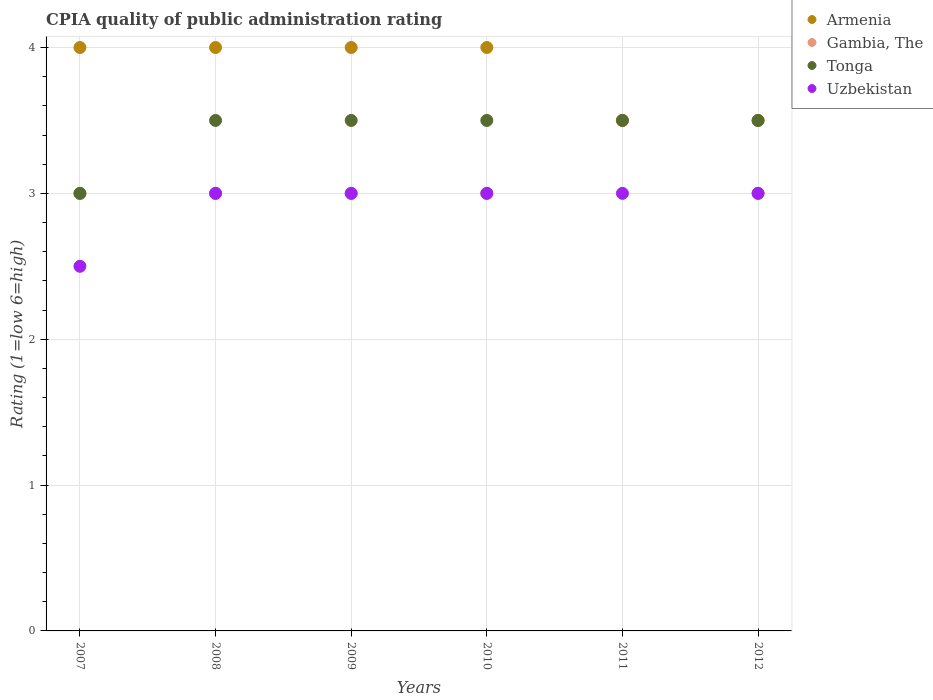How many different coloured dotlines are there?
Your answer should be compact. 4. Is the number of dotlines equal to the number of legend labels?
Provide a succinct answer. Yes. Across all years, what is the maximum CPIA rating in Armenia?
Offer a terse response. 4. Across all years, what is the minimum CPIA rating in Gambia, The?
Give a very brief answer. 3. In which year was the CPIA rating in Gambia, The minimum?
Offer a terse response. 2007. What is the total CPIA rating in Tonga in the graph?
Offer a terse response. 20.5. What is the difference between the CPIA rating in Gambia, The in 2011 and the CPIA rating in Uzbekistan in 2007?
Offer a terse response. 1. What is the average CPIA rating in Uzbekistan per year?
Ensure brevity in your answer.  2.92. In the year 2008, what is the difference between the CPIA rating in Uzbekistan and CPIA rating in Armenia?
Offer a terse response. -1. What is the ratio of the CPIA rating in Tonga in 2007 to that in 2010?
Your answer should be compact. 0.86. What is the difference between the highest and the second highest CPIA rating in Tonga?
Provide a succinct answer. 0. What is the difference between the highest and the lowest CPIA rating in Tonga?
Keep it short and to the point. 0.5. In how many years, is the CPIA rating in Armenia greater than the average CPIA rating in Armenia taken over all years?
Give a very brief answer. 4. Is it the case that in every year, the sum of the CPIA rating in Armenia and CPIA rating in Uzbekistan  is greater than the sum of CPIA rating in Gambia, The and CPIA rating in Tonga?
Provide a succinct answer. No. Is it the case that in every year, the sum of the CPIA rating in Tonga and CPIA rating in Gambia, The  is greater than the CPIA rating in Uzbekistan?
Your response must be concise. Yes. Does the CPIA rating in Tonga monotonically increase over the years?
Offer a terse response. No. Is the CPIA rating in Armenia strictly greater than the CPIA rating in Uzbekistan over the years?
Your answer should be very brief. Yes. How many dotlines are there?
Ensure brevity in your answer.  4. How many years are there in the graph?
Provide a short and direct response. 6. What is the difference between two consecutive major ticks on the Y-axis?
Keep it short and to the point. 1. Does the graph contain any zero values?
Offer a terse response. No. Does the graph contain grids?
Give a very brief answer. Yes. Where does the legend appear in the graph?
Provide a succinct answer. Top right. How many legend labels are there?
Your answer should be compact. 4. How are the legend labels stacked?
Give a very brief answer. Vertical. What is the title of the graph?
Give a very brief answer. CPIA quality of public administration rating. What is the Rating (1=low 6=high) of Armenia in 2007?
Offer a very short reply. 4. What is the Rating (1=low 6=high) of Tonga in 2007?
Provide a short and direct response. 3. What is the Rating (1=low 6=high) in Armenia in 2008?
Ensure brevity in your answer.  4. What is the Rating (1=low 6=high) of Uzbekistan in 2008?
Provide a short and direct response. 3. What is the Rating (1=low 6=high) of Gambia, The in 2009?
Give a very brief answer. 3. What is the Rating (1=low 6=high) of Tonga in 2009?
Make the answer very short. 3.5. What is the Rating (1=low 6=high) of Uzbekistan in 2009?
Make the answer very short. 3. What is the Rating (1=low 6=high) of Tonga in 2010?
Ensure brevity in your answer.  3.5. What is the Rating (1=low 6=high) in Uzbekistan in 2010?
Your answer should be compact. 3. What is the Rating (1=low 6=high) in Gambia, The in 2011?
Provide a short and direct response. 3.5. What is the Rating (1=low 6=high) in Tonga in 2011?
Ensure brevity in your answer.  3.5. What is the Rating (1=low 6=high) in Uzbekistan in 2011?
Ensure brevity in your answer.  3. What is the Rating (1=low 6=high) of Armenia in 2012?
Ensure brevity in your answer.  3.5. What is the Rating (1=low 6=high) of Tonga in 2012?
Ensure brevity in your answer.  3.5. Across all years, what is the maximum Rating (1=low 6=high) in Armenia?
Your answer should be compact. 4. Across all years, what is the maximum Rating (1=low 6=high) in Gambia, The?
Provide a short and direct response. 3.5. Across all years, what is the maximum Rating (1=low 6=high) in Tonga?
Make the answer very short. 3.5. Across all years, what is the minimum Rating (1=low 6=high) of Tonga?
Give a very brief answer. 3. What is the total Rating (1=low 6=high) of Tonga in the graph?
Ensure brevity in your answer.  20.5. What is the total Rating (1=low 6=high) in Uzbekistan in the graph?
Provide a short and direct response. 17.5. What is the difference between the Rating (1=low 6=high) of Uzbekistan in 2007 and that in 2008?
Offer a very short reply. -0.5. What is the difference between the Rating (1=low 6=high) of Armenia in 2007 and that in 2009?
Provide a short and direct response. 0. What is the difference between the Rating (1=low 6=high) in Gambia, The in 2007 and that in 2009?
Keep it short and to the point. 0. What is the difference between the Rating (1=low 6=high) of Uzbekistan in 2007 and that in 2009?
Your response must be concise. -0.5. What is the difference between the Rating (1=low 6=high) in Uzbekistan in 2007 and that in 2010?
Give a very brief answer. -0.5. What is the difference between the Rating (1=low 6=high) of Armenia in 2007 and that in 2011?
Offer a terse response. 0.5. What is the difference between the Rating (1=low 6=high) in Uzbekistan in 2007 and that in 2011?
Offer a very short reply. -0.5. What is the difference between the Rating (1=low 6=high) in Armenia in 2007 and that in 2012?
Your answer should be compact. 0.5. What is the difference between the Rating (1=low 6=high) of Gambia, The in 2007 and that in 2012?
Give a very brief answer. 0. What is the difference between the Rating (1=low 6=high) in Tonga in 2007 and that in 2012?
Your answer should be compact. -0.5. What is the difference between the Rating (1=low 6=high) of Gambia, The in 2008 and that in 2009?
Offer a very short reply. 0. What is the difference between the Rating (1=low 6=high) in Tonga in 2008 and that in 2009?
Your answer should be very brief. 0. What is the difference between the Rating (1=low 6=high) of Uzbekistan in 2008 and that in 2009?
Keep it short and to the point. 0. What is the difference between the Rating (1=low 6=high) of Armenia in 2008 and that in 2010?
Give a very brief answer. 0. What is the difference between the Rating (1=low 6=high) in Gambia, The in 2008 and that in 2010?
Ensure brevity in your answer.  0. What is the difference between the Rating (1=low 6=high) of Tonga in 2008 and that in 2010?
Offer a terse response. 0. What is the difference between the Rating (1=low 6=high) of Uzbekistan in 2008 and that in 2010?
Your answer should be very brief. 0. What is the difference between the Rating (1=low 6=high) of Armenia in 2008 and that in 2011?
Your answer should be compact. 0.5. What is the difference between the Rating (1=low 6=high) of Armenia in 2008 and that in 2012?
Offer a terse response. 0.5. What is the difference between the Rating (1=low 6=high) of Gambia, The in 2009 and that in 2010?
Your answer should be compact. 0. What is the difference between the Rating (1=low 6=high) in Tonga in 2009 and that in 2010?
Make the answer very short. 0. What is the difference between the Rating (1=low 6=high) of Uzbekistan in 2009 and that in 2010?
Ensure brevity in your answer.  0. What is the difference between the Rating (1=low 6=high) in Uzbekistan in 2009 and that in 2011?
Your answer should be compact. 0. What is the difference between the Rating (1=low 6=high) of Armenia in 2009 and that in 2012?
Provide a succinct answer. 0.5. What is the difference between the Rating (1=low 6=high) in Tonga in 2009 and that in 2012?
Your response must be concise. 0. What is the difference between the Rating (1=low 6=high) in Uzbekistan in 2009 and that in 2012?
Make the answer very short. 0. What is the difference between the Rating (1=low 6=high) of Armenia in 2010 and that in 2011?
Your answer should be very brief. 0.5. What is the difference between the Rating (1=low 6=high) of Tonga in 2010 and that in 2011?
Provide a short and direct response. 0. What is the difference between the Rating (1=low 6=high) of Uzbekistan in 2010 and that in 2011?
Provide a short and direct response. 0. What is the difference between the Rating (1=low 6=high) in Armenia in 2010 and that in 2012?
Your response must be concise. 0.5. What is the difference between the Rating (1=low 6=high) of Gambia, The in 2010 and that in 2012?
Offer a very short reply. 0. What is the difference between the Rating (1=low 6=high) in Tonga in 2010 and that in 2012?
Make the answer very short. 0. What is the difference between the Rating (1=low 6=high) of Uzbekistan in 2010 and that in 2012?
Give a very brief answer. 0. What is the difference between the Rating (1=low 6=high) of Gambia, The in 2011 and that in 2012?
Give a very brief answer. 0.5. What is the difference between the Rating (1=low 6=high) in Uzbekistan in 2011 and that in 2012?
Keep it short and to the point. 0. What is the difference between the Rating (1=low 6=high) in Armenia in 2007 and the Rating (1=low 6=high) in Gambia, The in 2008?
Keep it short and to the point. 1. What is the difference between the Rating (1=low 6=high) of Armenia in 2007 and the Rating (1=low 6=high) of Tonga in 2008?
Your answer should be very brief. 0.5. What is the difference between the Rating (1=low 6=high) in Gambia, The in 2007 and the Rating (1=low 6=high) in Uzbekistan in 2008?
Make the answer very short. 0. What is the difference between the Rating (1=low 6=high) of Tonga in 2007 and the Rating (1=low 6=high) of Uzbekistan in 2008?
Give a very brief answer. 0. What is the difference between the Rating (1=low 6=high) of Gambia, The in 2007 and the Rating (1=low 6=high) of Tonga in 2009?
Your response must be concise. -0.5. What is the difference between the Rating (1=low 6=high) in Gambia, The in 2007 and the Rating (1=low 6=high) in Uzbekistan in 2009?
Offer a terse response. 0. What is the difference between the Rating (1=low 6=high) of Armenia in 2007 and the Rating (1=low 6=high) of Gambia, The in 2010?
Your answer should be compact. 1. What is the difference between the Rating (1=low 6=high) of Tonga in 2007 and the Rating (1=low 6=high) of Uzbekistan in 2010?
Provide a succinct answer. 0. What is the difference between the Rating (1=low 6=high) of Armenia in 2007 and the Rating (1=low 6=high) of Gambia, The in 2011?
Give a very brief answer. 0.5. What is the difference between the Rating (1=low 6=high) in Armenia in 2007 and the Rating (1=low 6=high) in Tonga in 2011?
Provide a short and direct response. 0.5. What is the difference between the Rating (1=low 6=high) of Armenia in 2007 and the Rating (1=low 6=high) of Uzbekistan in 2011?
Your response must be concise. 1. What is the difference between the Rating (1=low 6=high) of Gambia, The in 2007 and the Rating (1=low 6=high) of Tonga in 2011?
Your answer should be compact. -0.5. What is the difference between the Rating (1=low 6=high) in Tonga in 2007 and the Rating (1=low 6=high) in Uzbekistan in 2011?
Provide a short and direct response. 0. What is the difference between the Rating (1=low 6=high) in Armenia in 2007 and the Rating (1=low 6=high) in Uzbekistan in 2012?
Your answer should be very brief. 1. What is the difference between the Rating (1=low 6=high) in Gambia, The in 2007 and the Rating (1=low 6=high) in Uzbekistan in 2012?
Your answer should be very brief. 0. What is the difference between the Rating (1=low 6=high) of Armenia in 2008 and the Rating (1=low 6=high) of Gambia, The in 2009?
Make the answer very short. 1. What is the difference between the Rating (1=low 6=high) in Armenia in 2008 and the Rating (1=low 6=high) in Tonga in 2009?
Provide a short and direct response. 0.5. What is the difference between the Rating (1=low 6=high) in Tonga in 2008 and the Rating (1=low 6=high) in Uzbekistan in 2009?
Ensure brevity in your answer.  0.5. What is the difference between the Rating (1=low 6=high) of Armenia in 2008 and the Rating (1=low 6=high) of Gambia, The in 2010?
Ensure brevity in your answer.  1. What is the difference between the Rating (1=low 6=high) in Armenia in 2008 and the Rating (1=low 6=high) in Uzbekistan in 2010?
Give a very brief answer. 1. What is the difference between the Rating (1=low 6=high) in Gambia, The in 2008 and the Rating (1=low 6=high) in Tonga in 2010?
Your answer should be compact. -0.5. What is the difference between the Rating (1=low 6=high) of Gambia, The in 2008 and the Rating (1=low 6=high) of Uzbekistan in 2010?
Your answer should be very brief. 0. What is the difference between the Rating (1=low 6=high) of Armenia in 2008 and the Rating (1=low 6=high) of Uzbekistan in 2011?
Your answer should be very brief. 1. What is the difference between the Rating (1=low 6=high) of Gambia, The in 2008 and the Rating (1=low 6=high) of Uzbekistan in 2011?
Your answer should be very brief. 0. What is the difference between the Rating (1=low 6=high) in Armenia in 2008 and the Rating (1=low 6=high) in Gambia, The in 2012?
Your response must be concise. 1. What is the difference between the Rating (1=low 6=high) of Armenia in 2008 and the Rating (1=low 6=high) of Tonga in 2012?
Make the answer very short. 0.5. What is the difference between the Rating (1=low 6=high) of Armenia in 2008 and the Rating (1=low 6=high) of Uzbekistan in 2012?
Make the answer very short. 1. What is the difference between the Rating (1=low 6=high) in Tonga in 2008 and the Rating (1=low 6=high) in Uzbekistan in 2012?
Offer a terse response. 0.5. What is the difference between the Rating (1=low 6=high) of Armenia in 2009 and the Rating (1=low 6=high) of Gambia, The in 2010?
Provide a succinct answer. 1. What is the difference between the Rating (1=low 6=high) of Armenia in 2009 and the Rating (1=low 6=high) of Tonga in 2010?
Your response must be concise. 0.5. What is the difference between the Rating (1=low 6=high) in Gambia, The in 2009 and the Rating (1=low 6=high) in Tonga in 2010?
Make the answer very short. -0.5. What is the difference between the Rating (1=low 6=high) in Armenia in 2009 and the Rating (1=low 6=high) in Gambia, The in 2011?
Give a very brief answer. 0.5. What is the difference between the Rating (1=low 6=high) in Armenia in 2009 and the Rating (1=low 6=high) in Tonga in 2011?
Provide a short and direct response. 0.5. What is the difference between the Rating (1=low 6=high) of Armenia in 2009 and the Rating (1=low 6=high) of Uzbekistan in 2011?
Keep it short and to the point. 1. What is the difference between the Rating (1=low 6=high) of Gambia, The in 2009 and the Rating (1=low 6=high) of Uzbekistan in 2011?
Provide a succinct answer. 0. What is the difference between the Rating (1=low 6=high) of Armenia in 2009 and the Rating (1=low 6=high) of Tonga in 2012?
Offer a terse response. 0.5. What is the difference between the Rating (1=low 6=high) in Armenia in 2009 and the Rating (1=low 6=high) in Uzbekistan in 2012?
Make the answer very short. 1. What is the difference between the Rating (1=low 6=high) of Armenia in 2010 and the Rating (1=low 6=high) of Tonga in 2011?
Your response must be concise. 0.5. What is the difference between the Rating (1=low 6=high) of Armenia in 2010 and the Rating (1=low 6=high) of Uzbekistan in 2011?
Your answer should be compact. 1. What is the difference between the Rating (1=low 6=high) in Tonga in 2010 and the Rating (1=low 6=high) in Uzbekistan in 2011?
Your answer should be compact. 0.5. What is the difference between the Rating (1=low 6=high) of Armenia in 2010 and the Rating (1=low 6=high) of Gambia, The in 2012?
Offer a very short reply. 1. What is the difference between the Rating (1=low 6=high) of Gambia, The in 2010 and the Rating (1=low 6=high) of Tonga in 2012?
Your answer should be very brief. -0.5. What is the difference between the Rating (1=low 6=high) in Tonga in 2010 and the Rating (1=low 6=high) in Uzbekistan in 2012?
Your response must be concise. 0.5. What is the difference between the Rating (1=low 6=high) in Armenia in 2011 and the Rating (1=low 6=high) in Gambia, The in 2012?
Give a very brief answer. 0.5. What is the difference between the Rating (1=low 6=high) in Armenia in 2011 and the Rating (1=low 6=high) in Tonga in 2012?
Your answer should be compact. 0. What is the difference between the Rating (1=low 6=high) of Tonga in 2011 and the Rating (1=low 6=high) of Uzbekistan in 2012?
Offer a very short reply. 0.5. What is the average Rating (1=low 6=high) in Armenia per year?
Provide a short and direct response. 3.83. What is the average Rating (1=low 6=high) in Gambia, The per year?
Make the answer very short. 3.08. What is the average Rating (1=low 6=high) of Tonga per year?
Provide a short and direct response. 3.42. What is the average Rating (1=low 6=high) of Uzbekistan per year?
Your answer should be compact. 2.92. In the year 2007, what is the difference between the Rating (1=low 6=high) of Armenia and Rating (1=low 6=high) of Tonga?
Give a very brief answer. 1. In the year 2007, what is the difference between the Rating (1=low 6=high) of Gambia, The and Rating (1=low 6=high) of Uzbekistan?
Offer a terse response. 0.5. In the year 2007, what is the difference between the Rating (1=low 6=high) of Tonga and Rating (1=low 6=high) of Uzbekistan?
Provide a short and direct response. 0.5. In the year 2008, what is the difference between the Rating (1=low 6=high) in Gambia, The and Rating (1=low 6=high) in Tonga?
Give a very brief answer. -0.5. In the year 2008, what is the difference between the Rating (1=low 6=high) of Gambia, The and Rating (1=low 6=high) of Uzbekistan?
Your response must be concise. 0. In the year 2009, what is the difference between the Rating (1=low 6=high) in Armenia and Rating (1=low 6=high) in Gambia, The?
Keep it short and to the point. 1. In the year 2010, what is the difference between the Rating (1=low 6=high) of Armenia and Rating (1=low 6=high) of Gambia, The?
Offer a very short reply. 1. In the year 2010, what is the difference between the Rating (1=low 6=high) of Armenia and Rating (1=low 6=high) of Uzbekistan?
Ensure brevity in your answer.  1. In the year 2010, what is the difference between the Rating (1=low 6=high) in Gambia, The and Rating (1=low 6=high) in Uzbekistan?
Your answer should be compact. 0. In the year 2010, what is the difference between the Rating (1=low 6=high) of Tonga and Rating (1=low 6=high) of Uzbekistan?
Provide a succinct answer. 0.5. In the year 2011, what is the difference between the Rating (1=low 6=high) of Armenia and Rating (1=low 6=high) of Gambia, The?
Ensure brevity in your answer.  0. In the year 2011, what is the difference between the Rating (1=low 6=high) in Gambia, The and Rating (1=low 6=high) in Uzbekistan?
Give a very brief answer. 0.5. In the year 2011, what is the difference between the Rating (1=low 6=high) in Tonga and Rating (1=low 6=high) in Uzbekistan?
Your answer should be very brief. 0.5. In the year 2012, what is the difference between the Rating (1=low 6=high) of Armenia and Rating (1=low 6=high) of Gambia, The?
Your answer should be very brief. 0.5. In the year 2012, what is the difference between the Rating (1=low 6=high) in Armenia and Rating (1=low 6=high) in Tonga?
Your answer should be very brief. 0. In the year 2012, what is the difference between the Rating (1=low 6=high) in Gambia, The and Rating (1=low 6=high) in Tonga?
Your answer should be compact. -0.5. In the year 2012, what is the difference between the Rating (1=low 6=high) of Tonga and Rating (1=low 6=high) of Uzbekistan?
Make the answer very short. 0.5. What is the ratio of the Rating (1=low 6=high) of Armenia in 2007 to that in 2009?
Provide a succinct answer. 1. What is the ratio of the Rating (1=low 6=high) in Gambia, The in 2007 to that in 2009?
Make the answer very short. 1. What is the ratio of the Rating (1=low 6=high) in Tonga in 2007 to that in 2009?
Keep it short and to the point. 0.86. What is the ratio of the Rating (1=low 6=high) in Uzbekistan in 2007 to that in 2009?
Make the answer very short. 0.83. What is the ratio of the Rating (1=low 6=high) of Gambia, The in 2007 to that in 2010?
Provide a succinct answer. 1. What is the ratio of the Rating (1=low 6=high) in Armenia in 2007 to that in 2011?
Ensure brevity in your answer.  1.14. What is the ratio of the Rating (1=low 6=high) of Gambia, The in 2007 to that in 2011?
Your response must be concise. 0.86. What is the ratio of the Rating (1=low 6=high) in Tonga in 2007 to that in 2011?
Your answer should be very brief. 0.86. What is the ratio of the Rating (1=low 6=high) of Gambia, The in 2007 to that in 2012?
Your answer should be compact. 1. What is the ratio of the Rating (1=low 6=high) in Uzbekistan in 2007 to that in 2012?
Offer a terse response. 0.83. What is the ratio of the Rating (1=low 6=high) of Gambia, The in 2008 to that in 2009?
Your answer should be very brief. 1. What is the ratio of the Rating (1=low 6=high) of Gambia, The in 2008 to that in 2010?
Provide a succinct answer. 1. What is the ratio of the Rating (1=low 6=high) of Uzbekistan in 2008 to that in 2010?
Your answer should be very brief. 1. What is the ratio of the Rating (1=low 6=high) in Tonga in 2008 to that in 2011?
Give a very brief answer. 1. What is the ratio of the Rating (1=low 6=high) of Gambia, The in 2008 to that in 2012?
Keep it short and to the point. 1. What is the ratio of the Rating (1=low 6=high) in Gambia, The in 2009 to that in 2010?
Give a very brief answer. 1. What is the ratio of the Rating (1=low 6=high) in Uzbekistan in 2009 to that in 2010?
Offer a terse response. 1. What is the ratio of the Rating (1=low 6=high) in Gambia, The in 2009 to that in 2011?
Provide a short and direct response. 0.86. What is the ratio of the Rating (1=low 6=high) in Armenia in 2009 to that in 2012?
Offer a terse response. 1.14. What is the ratio of the Rating (1=low 6=high) in Armenia in 2010 to that in 2011?
Keep it short and to the point. 1.14. What is the ratio of the Rating (1=low 6=high) of Gambia, The in 2010 to that in 2011?
Keep it short and to the point. 0.86. What is the ratio of the Rating (1=low 6=high) in Tonga in 2010 to that in 2011?
Make the answer very short. 1. What is the ratio of the Rating (1=low 6=high) in Armenia in 2010 to that in 2012?
Give a very brief answer. 1.14. What is the ratio of the Rating (1=low 6=high) of Tonga in 2010 to that in 2012?
Ensure brevity in your answer.  1. What is the ratio of the Rating (1=low 6=high) in Armenia in 2011 to that in 2012?
Give a very brief answer. 1. What is the ratio of the Rating (1=low 6=high) in Tonga in 2011 to that in 2012?
Make the answer very short. 1. What is the difference between the highest and the second highest Rating (1=low 6=high) of Gambia, The?
Provide a short and direct response. 0.5. What is the difference between the highest and the second highest Rating (1=low 6=high) in Tonga?
Provide a short and direct response. 0. What is the difference between the highest and the lowest Rating (1=low 6=high) in Armenia?
Your answer should be very brief. 0.5. What is the difference between the highest and the lowest Rating (1=low 6=high) in Gambia, The?
Your answer should be compact. 0.5. What is the difference between the highest and the lowest Rating (1=low 6=high) of Tonga?
Your answer should be compact. 0.5. What is the difference between the highest and the lowest Rating (1=low 6=high) in Uzbekistan?
Your answer should be compact. 0.5. 